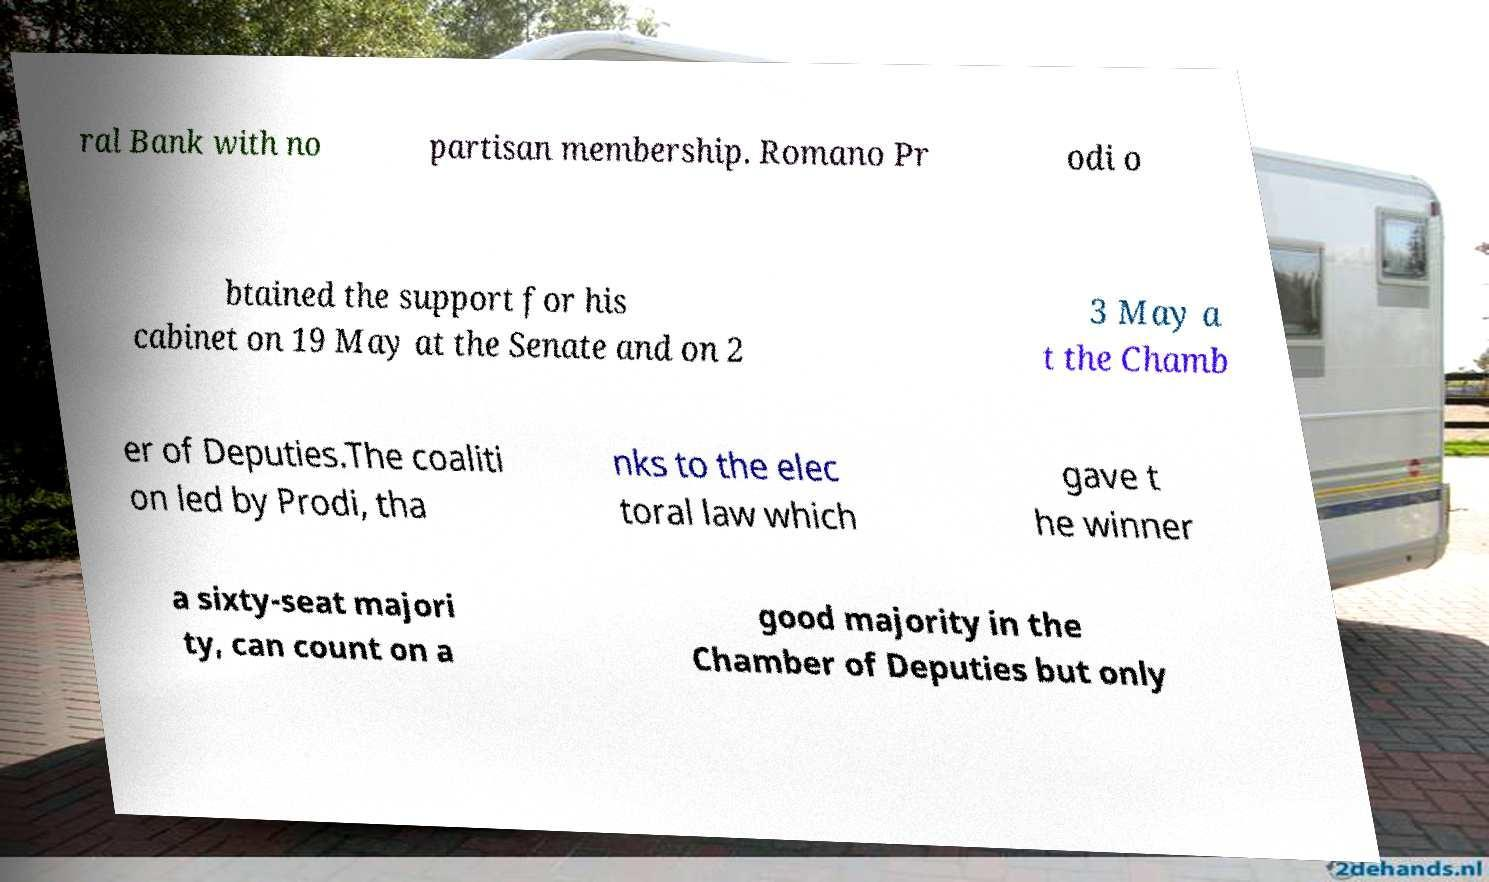Can you accurately transcribe the text from the provided image for me? ral Bank with no partisan membership. Romano Pr odi o btained the support for his cabinet on 19 May at the Senate and on 2 3 May a t the Chamb er of Deputies.The coaliti on led by Prodi, tha nks to the elec toral law which gave t he winner a sixty-seat majori ty, can count on a good majority in the Chamber of Deputies but only 